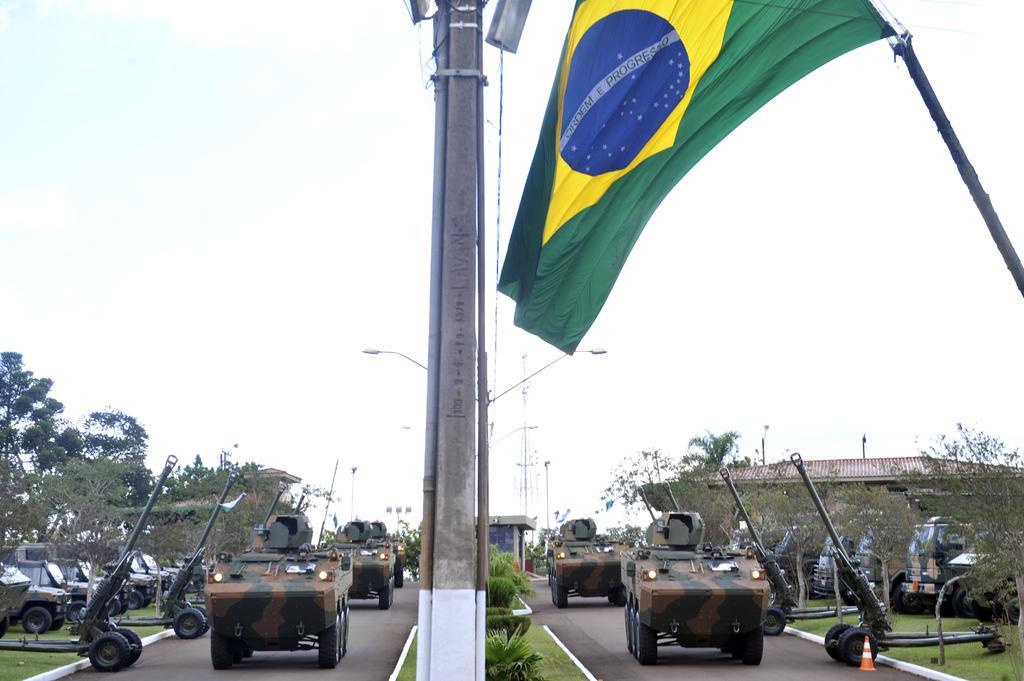Can you describe this image briefly? This is an outside view. Here I can see many vehicles on the road. In the middle of the road there is a divider on which I can see some plants and a pole. On the right and left side of the image I can see the trees. In the background there is a building. On the top of the image I can see the sky and also there is a green color flag. 